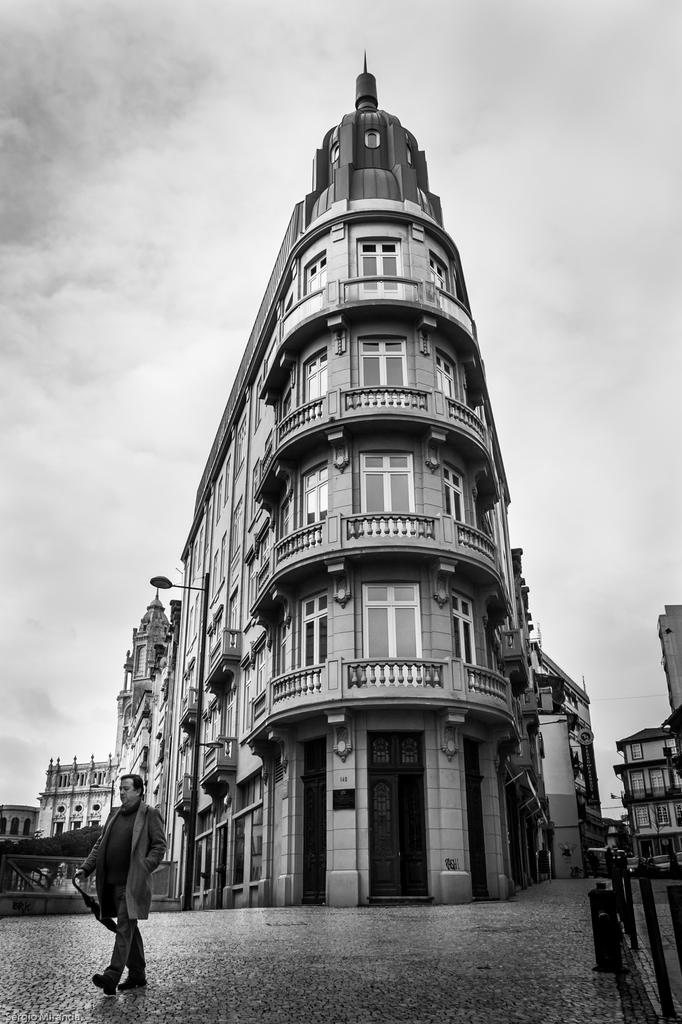What type of picture is shown in the image? The image contains a black and white picture of buildings. Can you describe the person in the image? There is a person walking in front of the buildings. What is the source of illumination near the buildings? There is a light near the buildings. What architectural feature can be seen on the walls of the buildings? There are rods on the wall of the buildings. What can be seen in the background of the image? The sky is visible in the background of the image. How many girls are playing with the iron in the image? There are no girls or iron present in the image. 